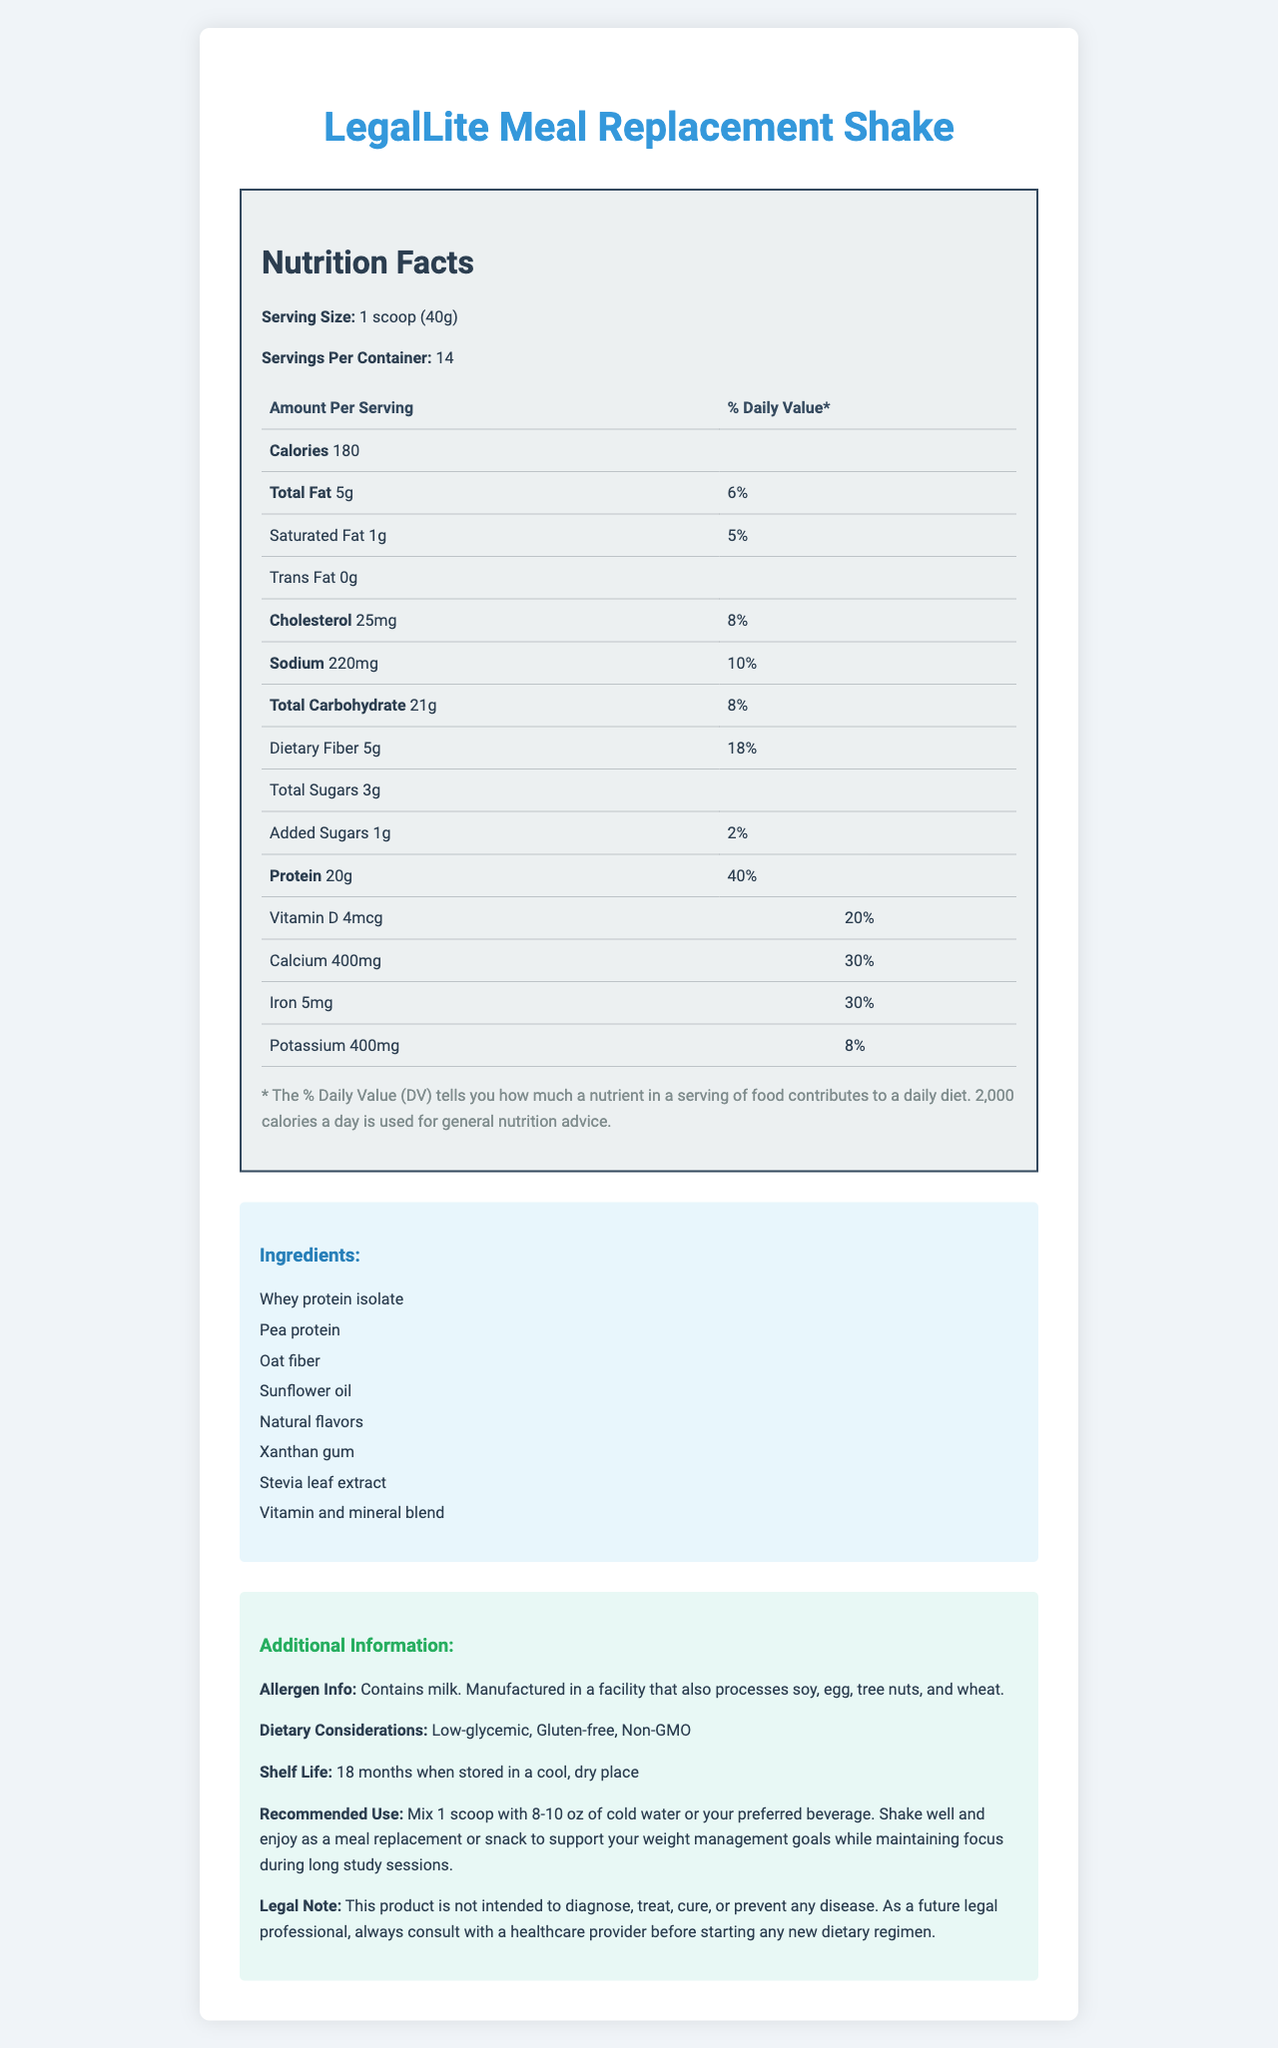what is the serving size? The serving size is specified as "1 scoop (40g)" in the first section of the document.
Answer: 1 scoop (40g) how many servings are in a container? The document states there are 14 servings per container.
Answer: 14 how many calories are there per serving? The document lists 180 calories per serving under the nutrition facts.
Answer: 180 how much protein is in each serving? According to the nutrition facts section, each serving contains 20g of protein.
Answer: 20g what is the percentage of daily value for dietary fiber? The daily value for dietary fiber is shown as 18% in the nutrition facts.
Answer: 18% what is the total amount of fat per serving? The total amount of fat per serving is 5g, according to the nutrition facts.
Answer: 5g how much saturated fat is there per serving? The document states that there is 1g of saturated fat per serving.
Answer: 1g what is the sodium content per serving? According to the document's nutrition facts, each serving contains 220mg of sodium.
Answer: 220mg how many added sugars are there in each serving? The nutrition facts section mentions that each serving contains 1g of added sugars.
Answer: 1g what are the main ingredients? The ingredients are listed in the ingredients section of the document.
Answer: Whey protein isolate, Pea protein, Oat fiber, Sunflower oil, Natural flavors, Xanthan gum, Stevia leaf extract, Vitamin and mineral blend how much calcium does each serving provide? Each serving provides 400mg of calcium, as stated in the nutrition facts.
Answer: 400mg what is the daily value percentage of vitamin D per serving? A. 10% B. 20% C. 30% D. 50% The document lists the daily value of vitamin D as 20% per serving.
Answer: B where are the allergens listed? The allergens are listed in the "Additional Information" section.
Answer: Contains milk. Manufactured in a facility that also processes soy, egg, tree nuts, and wheat. is the product gluten-free? The document specifies that the product is gluten-free under dietary considerations.
Answer: Yes what is the recommended use of this product? The recommended use is detailed in the additional information section of the document.
Answer: Mix 1 scoop with 8-10 oz of cold water or your preferred beverage. Shake well and enjoy as a meal replacement or snack to support your weight management goals while maintaining focus during long study sessions. summarize the main idea of the document. The document offers a detailed description of the nutrition facts, ingredients, allergen information, and recommended use for the LegalLite Meal Replacement Shake.
Answer: The document provides comprehensive nutrition facts, ingredient information, and additional details for the LegalLite Meal Replacement Shake, a meal replacement designed to support weight management. It details serving size, nutrients, daily values, and dietary considerations. how much potassium is there per serving? I. 200mg II. 300mg III. 400mg IV. 500mg The document lists the amount of potassium per serving as 400mg under the nutrition facts.
Answer: III which vitamin has the highest % daily value per serving? A. Vitamin A B. Vitamin C C. Vitamin B12 The document shows that vitamin B12 has the highest % daily value per serving at 125%.
Answer: C does the product contain soy? The allergen information states that the product is manufactured in a facility that also processes soy, but it does not specify if soy is a direct ingredient.
Answer: Not enough information what is the shelf life of the product? The document specifies a shelf life of 18 months when stored in a cool, dry place.
Answer: 18 months 